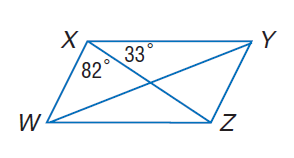Answer the mathemtical geometry problem and directly provide the correct option letter.
Question: W X Y Z is a parallelogram. Find m \angle Y Z W.
Choices: A: 33 B: 65 C: 82 D: 115 D 